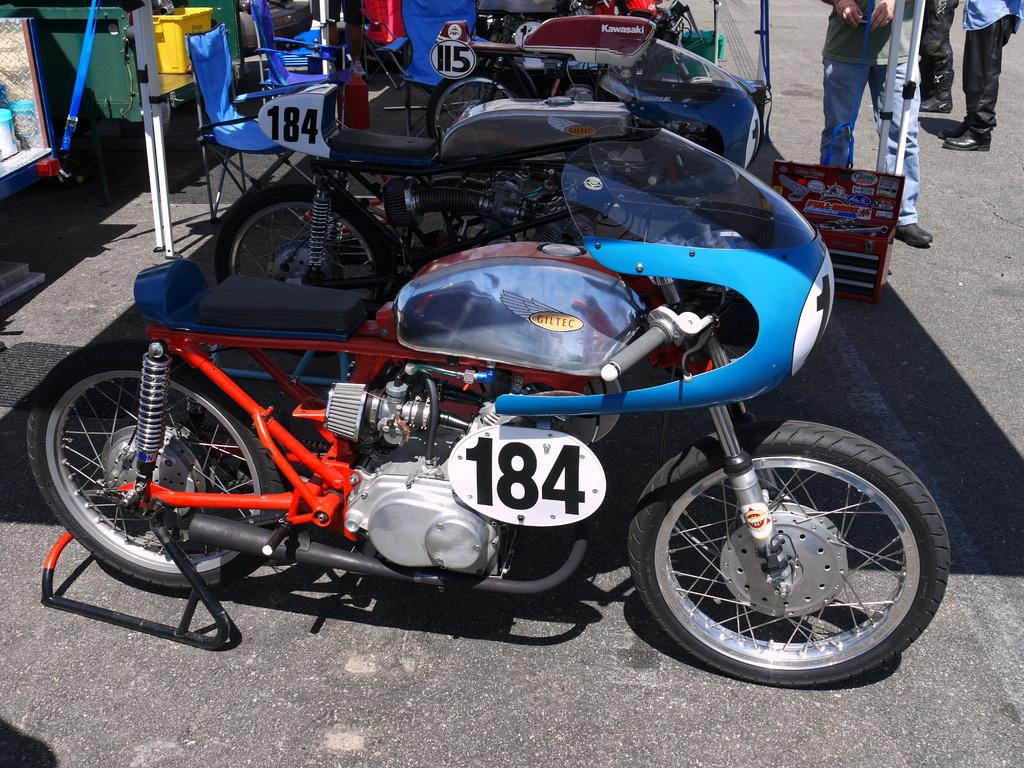What type of vehicles are in the image? There are motorcycles in the image. Who or what is on the road in the image? There are people on the road in the image. What can be seen in the background of the image? There is a basket, chairs, and other objects visible in the background of the image. What type of doll is sitting on the coal in the image? There is no doll or coal present in the image. 